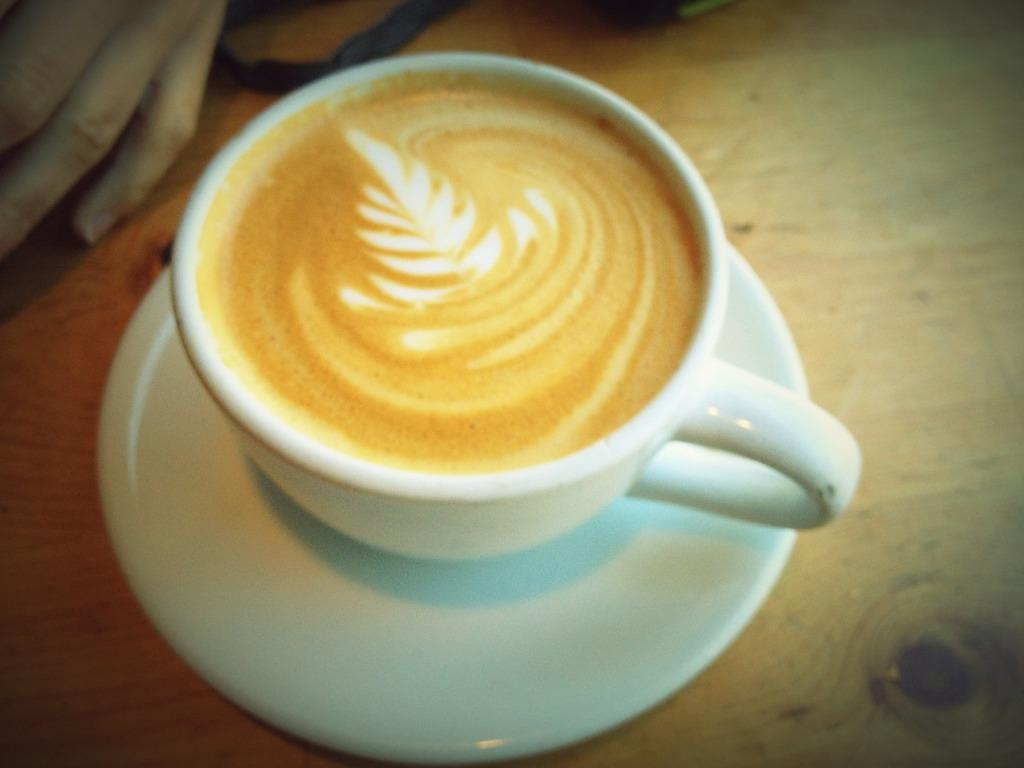What type of beverage is in the cup in the image? There is a cappuccino in a cup in the image. What is the cup resting on? The cup is on a saucer. Can you describe anything in the background of the image? There is a person's hand in the background of the image. What type of fruit is being peeled by the person in the image? There is no fruit present in the image; it only features a cappuccino in a cup on a saucer and a person's hand in the background. 